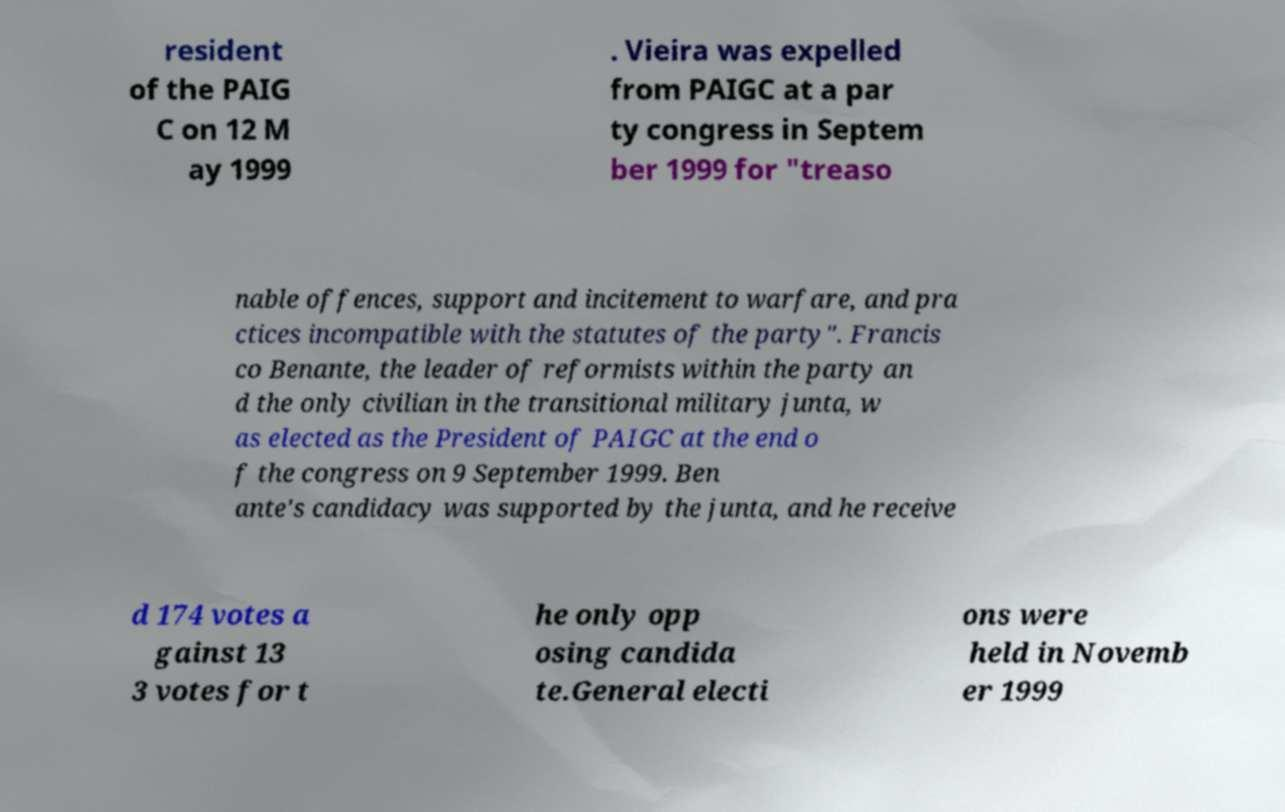I need the written content from this picture converted into text. Can you do that? resident of the PAIG C on 12 M ay 1999 . Vieira was expelled from PAIGC at a par ty congress in Septem ber 1999 for "treaso nable offences, support and incitement to warfare, and pra ctices incompatible with the statutes of the party". Francis co Benante, the leader of reformists within the party an d the only civilian in the transitional military junta, w as elected as the President of PAIGC at the end o f the congress on 9 September 1999. Ben ante's candidacy was supported by the junta, and he receive d 174 votes a gainst 13 3 votes for t he only opp osing candida te.General electi ons were held in Novemb er 1999 